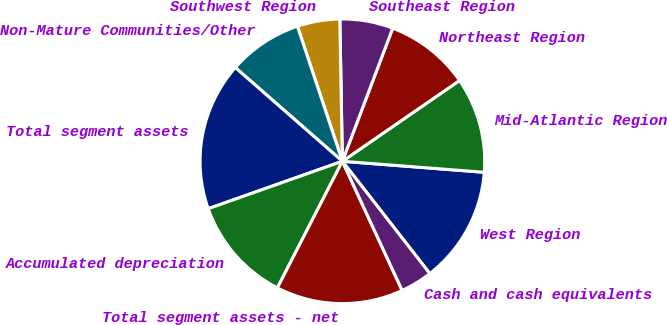<chart> <loc_0><loc_0><loc_500><loc_500><pie_chart><fcel>West Region<fcel>Mid-Atlantic Region<fcel>Northeast Region<fcel>Southeast Region<fcel>Southwest Region<fcel>Non-Mature Communities/Other<fcel>Total segment assets<fcel>Accumulated depreciation<fcel>Total segment assets - net<fcel>Cash and cash equivalents<nl><fcel>13.24%<fcel>10.84%<fcel>9.64%<fcel>6.04%<fcel>4.83%<fcel>8.44%<fcel>16.85%<fcel>12.04%<fcel>14.45%<fcel>3.63%<nl></chart> 